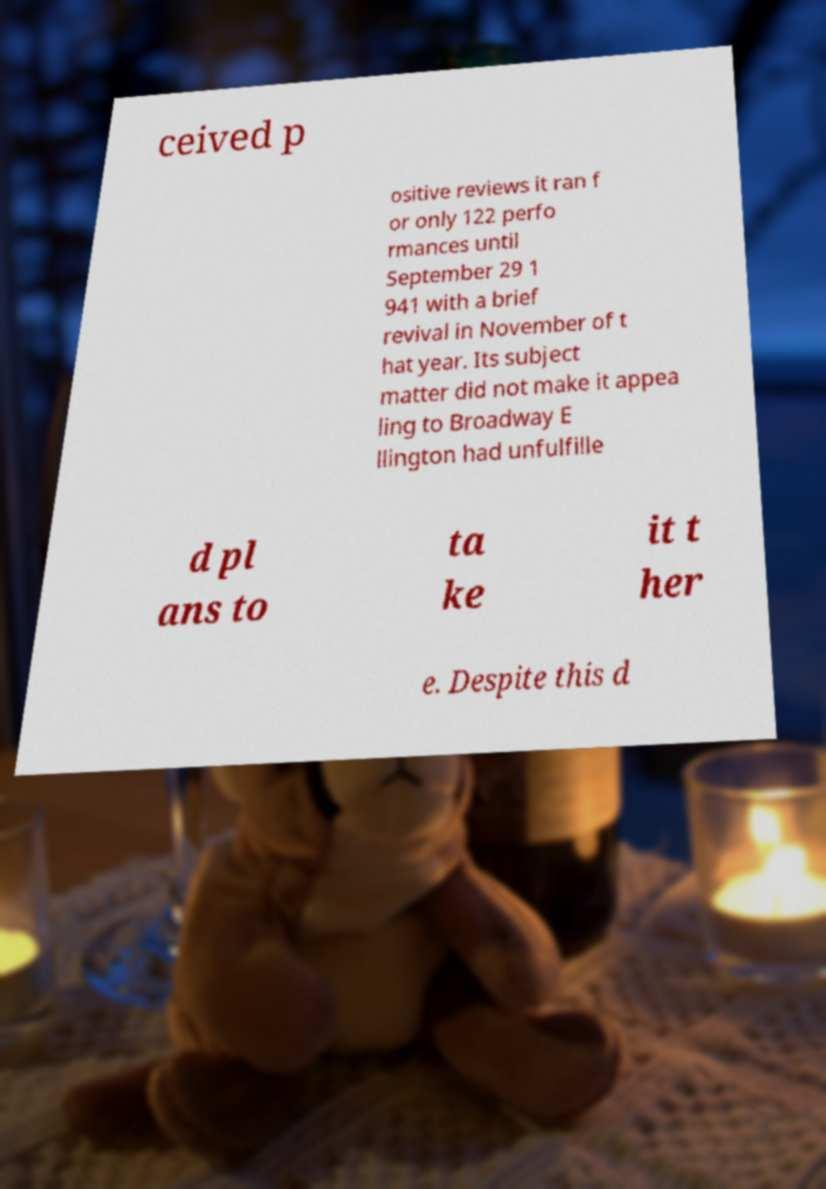Could you extract and type out the text from this image? ceived p ositive reviews it ran f or only 122 perfo rmances until September 29 1 941 with a brief revival in November of t hat year. Its subject matter did not make it appea ling to Broadway E llington had unfulfille d pl ans to ta ke it t her e. Despite this d 